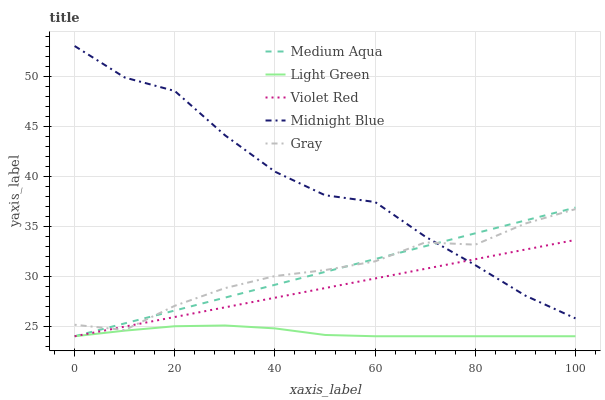Does Light Green have the minimum area under the curve?
Answer yes or no. Yes. Does Midnight Blue have the maximum area under the curve?
Answer yes or no. Yes. Does Violet Red have the minimum area under the curve?
Answer yes or no. No. Does Violet Red have the maximum area under the curve?
Answer yes or no. No. Is Violet Red the smoothest?
Answer yes or no. Yes. Is Midnight Blue the roughest?
Answer yes or no. Yes. Is Medium Aqua the smoothest?
Answer yes or no. No. Is Medium Aqua the roughest?
Answer yes or no. No. Does Violet Red have the lowest value?
Answer yes or no. Yes. Does Midnight Blue have the lowest value?
Answer yes or no. No. Does Midnight Blue have the highest value?
Answer yes or no. Yes. Does Violet Red have the highest value?
Answer yes or no. No. Is Light Green less than Midnight Blue?
Answer yes or no. Yes. Is Midnight Blue greater than Light Green?
Answer yes or no. Yes. Does Medium Aqua intersect Violet Red?
Answer yes or no. Yes. Is Medium Aqua less than Violet Red?
Answer yes or no. No. Is Medium Aqua greater than Violet Red?
Answer yes or no. No. Does Light Green intersect Midnight Blue?
Answer yes or no. No. 